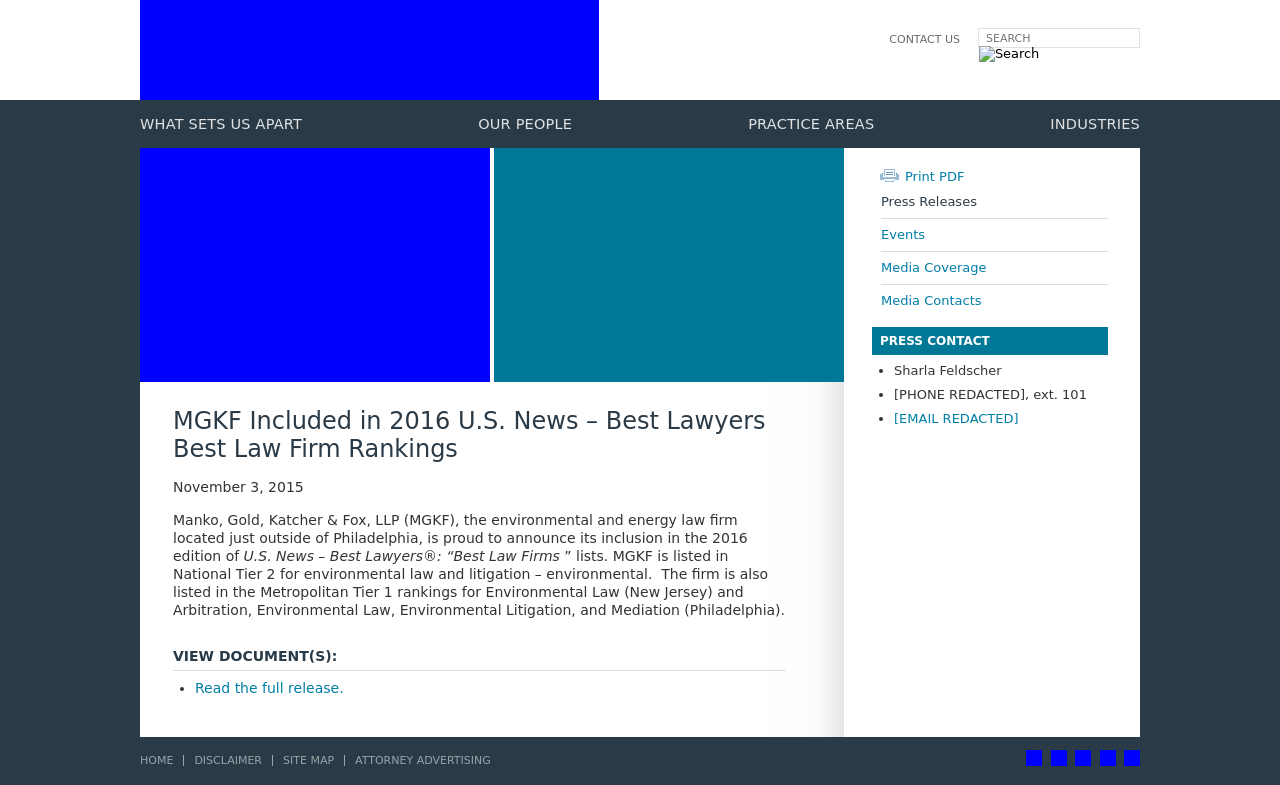Could you detail the process for assembling this website using HTML? Creating a website like the one shown in the image involves several steps. Initially, one would set up the basic HTML structure with a <!DOCTYPE> declaration, and <html> tags which include <head> and <body> sections. The <head> section typically contains meta tags, title tag, link tags for CSS, and script tags for JavaScript. The <body> generally hosts all content sections such as headers, navigation bars, the main content section shown in the image, and footers. CSS is used for styling and layout configurations whereas JavaScript manages interactivity. For dynamic content management, server-side scripting like PHP or a database might be used. The specific page shown focuses on the firm's inclusion in a law firm ranking by U.S. News – a section within the site that likely highlights significant accomplishments and press releases. 